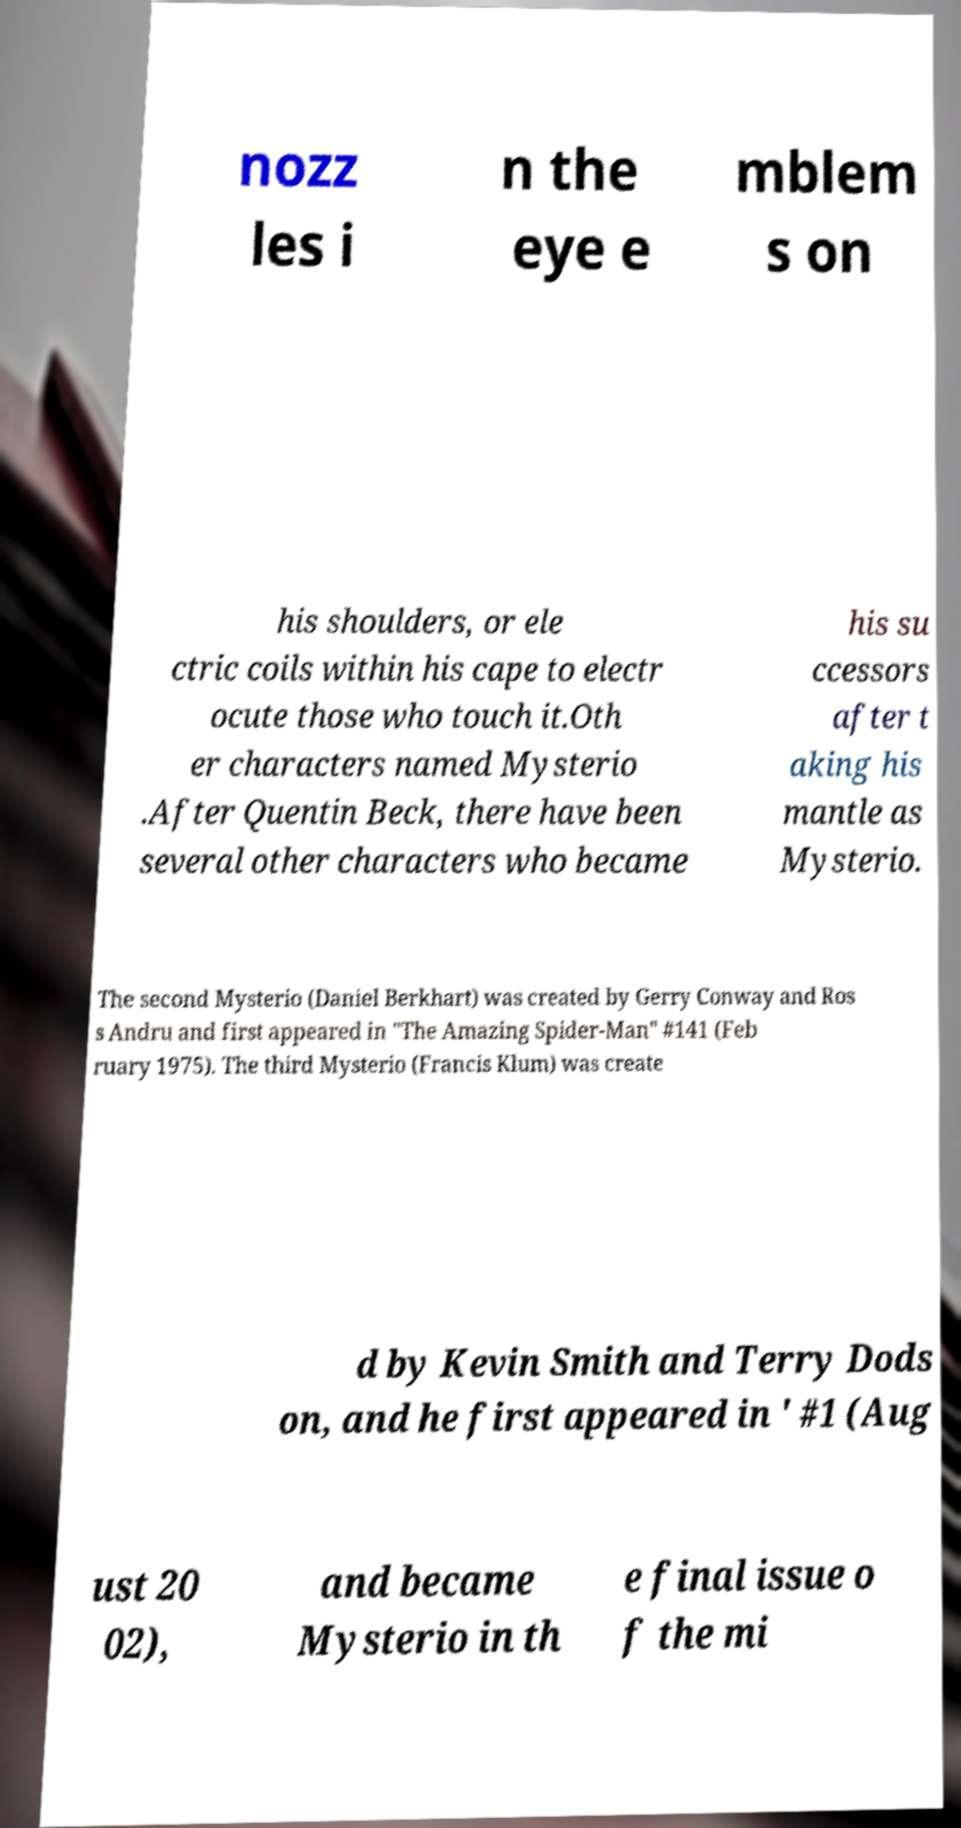For documentation purposes, I need the text within this image transcribed. Could you provide that? nozz les i n the eye e mblem s on his shoulders, or ele ctric coils within his cape to electr ocute those who touch it.Oth er characters named Mysterio .After Quentin Beck, there have been several other characters who became his su ccessors after t aking his mantle as Mysterio. The second Mysterio (Daniel Berkhart) was created by Gerry Conway and Ros s Andru and first appeared in "The Amazing Spider-Man" #141 (Feb ruary 1975). The third Mysterio (Francis Klum) was create d by Kevin Smith and Terry Dods on, and he first appeared in ' #1 (Aug ust 20 02), and became Mysterio in th e final issue o f the mi 